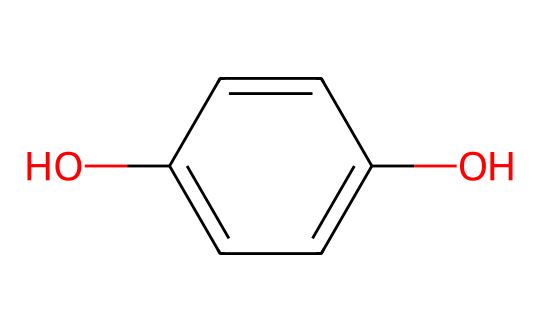What is the molecular formula of hydroquinone? The chemical structure can be analyzed based on the number of carbon (C), hydrogen (H), and oxygen (O) atoms present. Counting the atoms in the SMILES representation gives us 6 carbon atoms, 6 hydrogen atoms, and 2 oxygen atoms. Therefore, the molecular formula is C6H6O2.
Answer: C6H6O2 How many hydroxyl (OH) groups are present in hydroquinone? The structure can be seen to have two hydroxyl (-OH) groups attached to the benzene ring. Observing the positions indicated in the SMILES reveals that there are two occurrences of -OH groups.
Answer: 2 What type of chemical is hydroquinone? Hydroquinone is classified as a phenol due to its hydroxyl groups being attached to an aromatic ring. The presence of the benzene structure and -OH groups confirms its identity as a phenolic compound.
Answer: phenol How many double bonds are there in the hydroquinone structure? The structure reveals that there are no double bonds adjacent to each other, indicating the connectivity between carbon atoms and their hydrogen atoms without pi bonds. A close look confirms that the molecular composition contains only single bonds.
Answer: 0 What is the total number of carbon-carbon bonds in hydroquinone? Analyzing the structure shows that there are five carbon-carbon bonds in the benzene ring. This requires visualizing the connections between each benzene carbon to know how many bonds contribute to the total calculation.
Answer: 5 